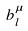Convert formula to latex. <formula><loc_0><loc_0><loc_500><loc_500>b _ { l } ^ { \mu }</formula> 